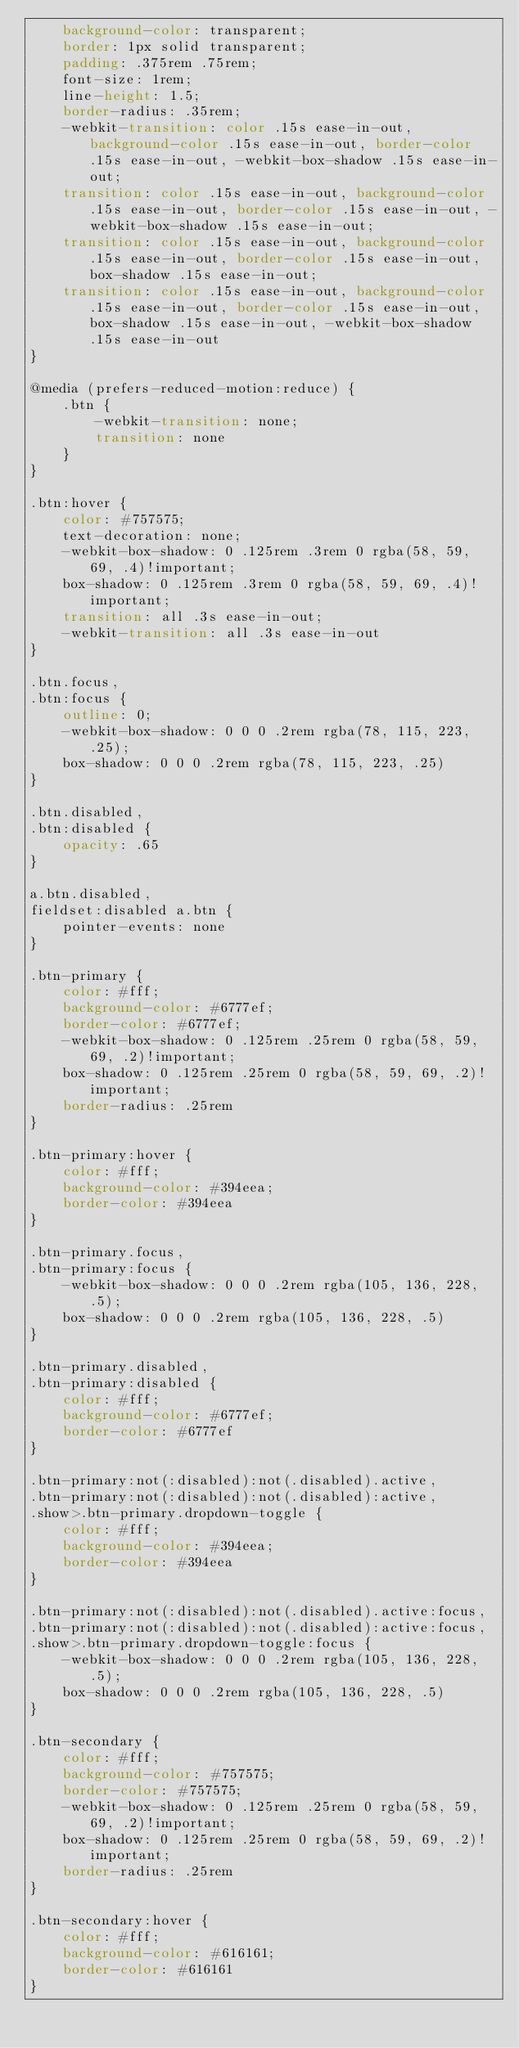<code> <loc_0><loc_0><loc_500><loc_500><_CSS_>    background-color: transparent;
    border: 1px solid transparent;
    padding: .375rem .75rem;
    font-size: 1rem;
    line-height: 1.5;
    border-radius: .35rem;
    -webkit-transition: color .15s ease-in-out, background-color .15s ease-in-out, border-color .15s ease-in-out, -webkit-box-shadow .15s ease-in-out;
    transition: color .15s ease-in-out, background-color .15s ease-in-out, border-color .15s ease-in-out, -webkit-box-shadow .15s ease-in-out;
    transition: color .15s ease-in-out, background-color .15s ease-in-out, border-color .15s ease-in-out, box-shadow .15s ease-in-out;
    transition: color .15s ease-in-out, background-color .15s ease-in-out, border-color .15s ease-in-out, box-shadow .15s ease-in-out, -webkit-box-shadow .15s ease-in-out
}

@media (prefers-reduced-motion:reduce) {
    .btn {
        -webkit-transition: none;
        transition: none
    }
}

.btn:hover {
    color: #757575;
    text-decoration: none;
    -webkit-box-shadow: 0 .125rem .3rem 0 rgba(58, 59, 69, .4)!important;
    box-shadow: 0 .125rem .3rem 0 rgba(58, 59, 69, .4)!important;
    transition: all .3s ease-in-out;
    -webkit-transition: all .3s ease-in-out
}

.btn.focus,
.btn:focus {
    outline: 0;
    -webkit-box-shadow: 0 0 0 .2rem rgba(78, 115, 223, .25);
    box-shadow: 0 0 0 .2rem rgba(78, 115, 223, .25)
}

.btn.disabled,
.btn:disabled {
    opacity: .65
}

a.btn.disabled,
fieldset:disabled a.btn {
    pointer-events: none
}

.btn-primary {
    color: #fff;
    background-color: #6777ef;
    border-color: #6777ef;
    -webkit-box-shadow: 0 .125rem .25rem 0 rgba(58, 59, 69, .2)!important;
    box-shadow: 0 .125rem .25rem 0 rgba(58, 59, 69, .2)!important;
    border-radius: .25rem
}

.btn-primary:hover {
    color: #fff;
    background-color: #394eea;
    border-color: #394eea
}

.btn-primary.focus,
.btn-primary:focus {
    -webkit-box-shadow: 0 0 0 .2rem rgba(105, 136, 228, .5);
    box-shadow: 0 0 0 .2rem rgba(105, 136, 228, .5)
}

.btn-primary.disabled,
.btn-primary:disabled {
    color: #fff;
    background-color: #6777ef;
    border-color: #6777ef
}

.btn-primary:not(:disabled):not(.disabled).active,
.btn-primary:not(:disabled):not(.disabled):active,
.show>.btn-primary.dropdown-toggle {
    color: #fff;
    background-color: #394eea;
    border-color: #394eea
}

.btn-primary:not(:disabled):not(.disabled).active:focus,
.btn-primary:not(:disabled):not(.disabled):active:focus,
.show>.btn-primary.dropdown-toggle:focus {
    -webkit-box-shadow: 0 0 0 .2rem rgba(105, 136, 228, .5);
    box-shadow: 0 0 0 .2rem rgba(105, 136, 228, .5)
}

.btn-secondary {
    color: #fff;
    background-color: #757575;
    border-color: #757575;
    -webkit-box-shadow: 0 .125rem .25rem 0 rgba(58, 59, 69, .2)!important;
    box-shadow: 0 .125rem .25rem 0 rgba(58, 59, 69, .2)!important;
    border-radius: .25rem
}

.btn-secondary:hover {
    color: #fff;
    background-color: #616161;
    border-color: #616161
}
</code> 